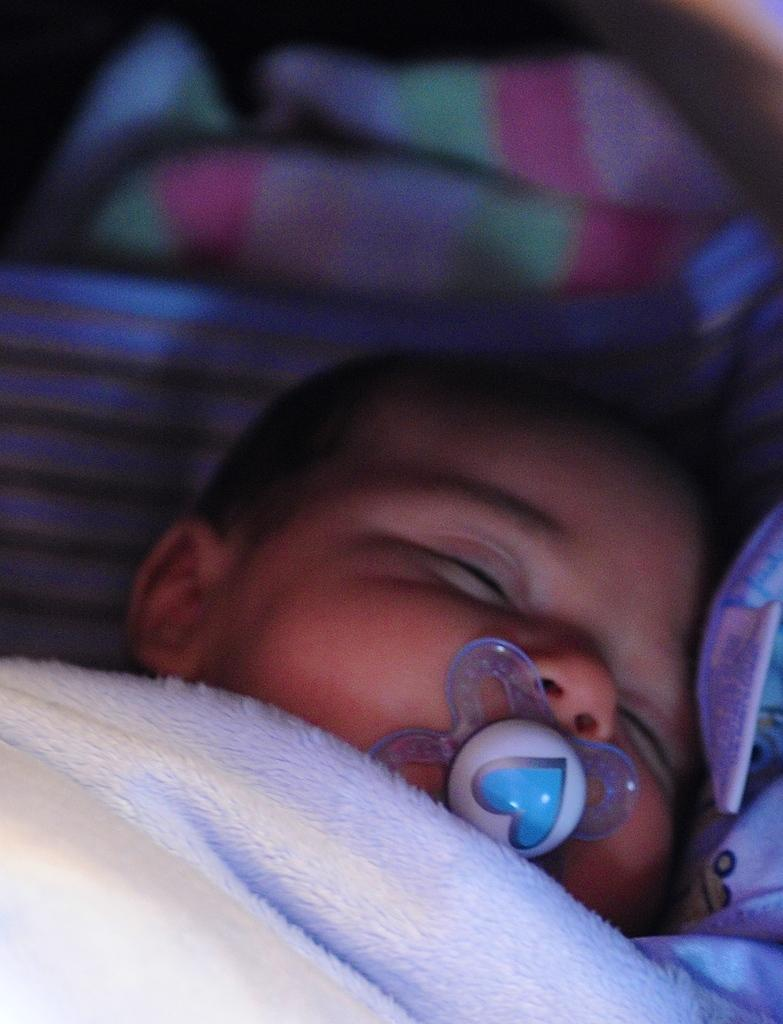What is the main subject of the image? There is a baby in the image. What is the baby doing in the image? The baby is sleeping on the bed. What can be seen at the bottom of the bed? There is a white color blanket at the bottom of the bed. Can you describe the top part of the image? The top of the image is blurry. What type of pot is being used to showcase the baby's event in the image? There is no pot or event present in the image; it features a baby sleeping on a bed with a white color blanket at the bottom. 